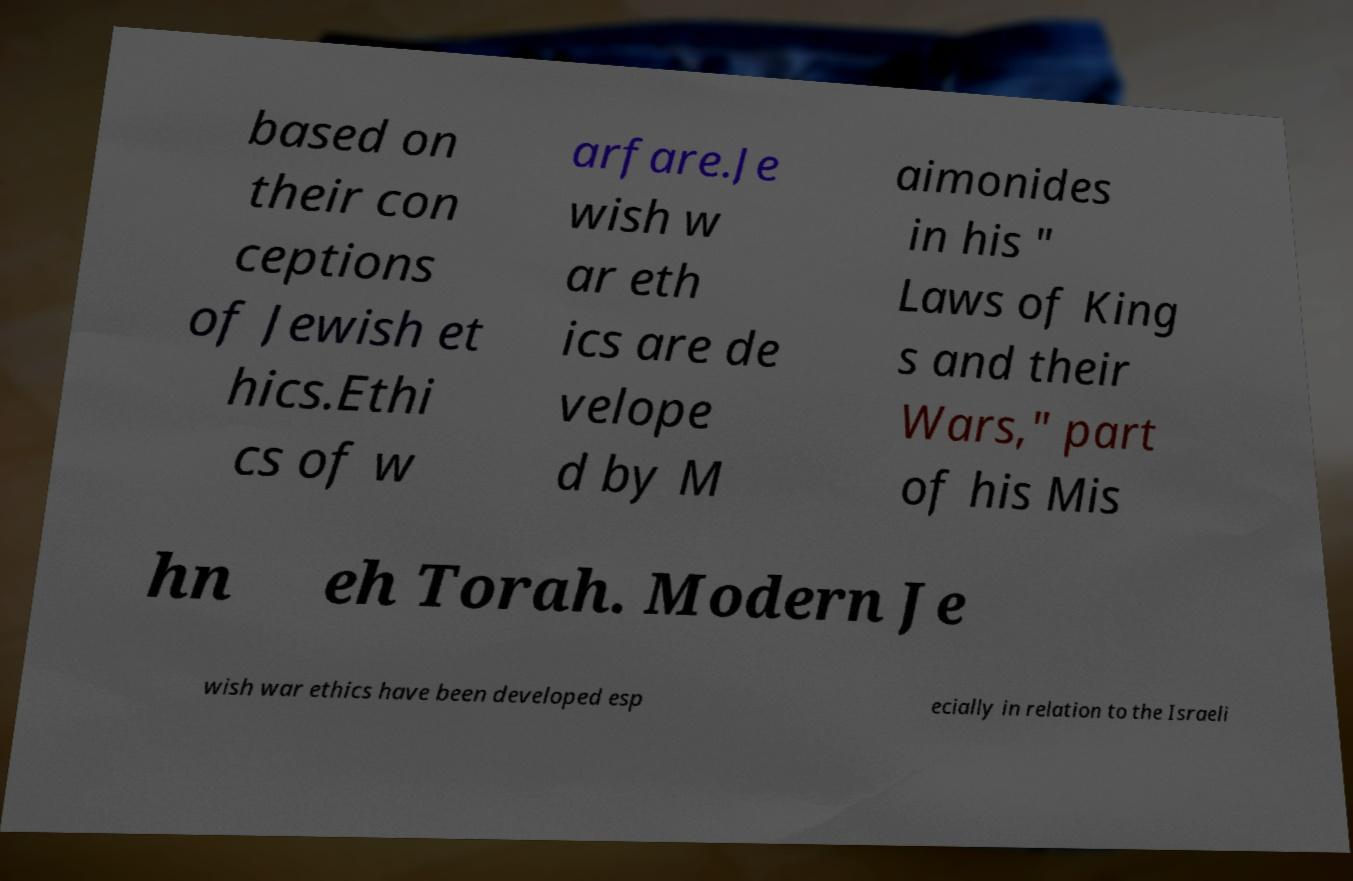Please identify and transcribe the text found in this image. based on their con ceptions of Jewish et hics.Ethi cs of w arfare.Je wish w ar eth ics are de velope d by M aimonides in his " Laws of King s and their Wars," part of his Mis hn eh Torah. Modern Je wish war ethics have been developed esp ecially in relation to the Israeli 